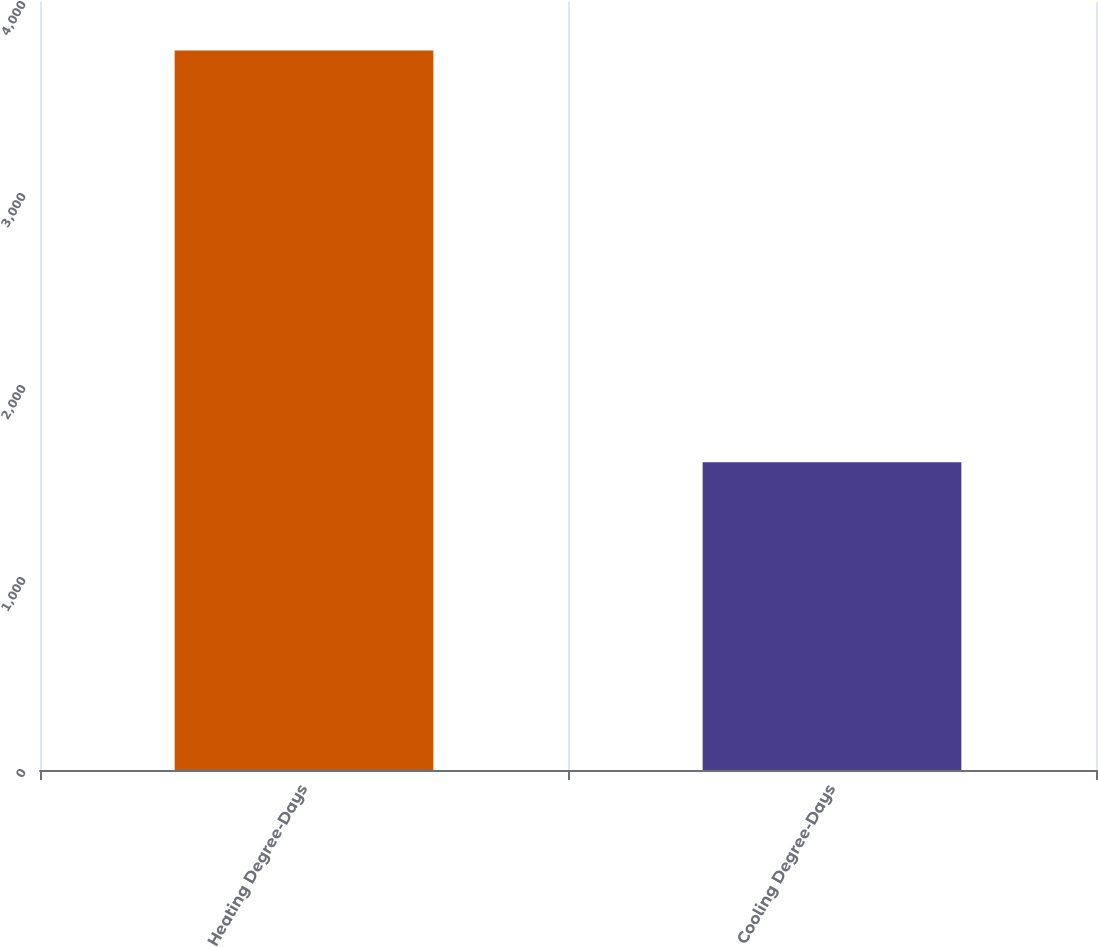<chart> <loc_0><loc_0><loc_500><loc_500><bar_chart><fcel>Heating Degree-Days<fcel>Cooling Degree-Days<nl><fcel>3747<fcel>1603<nl></chart> 